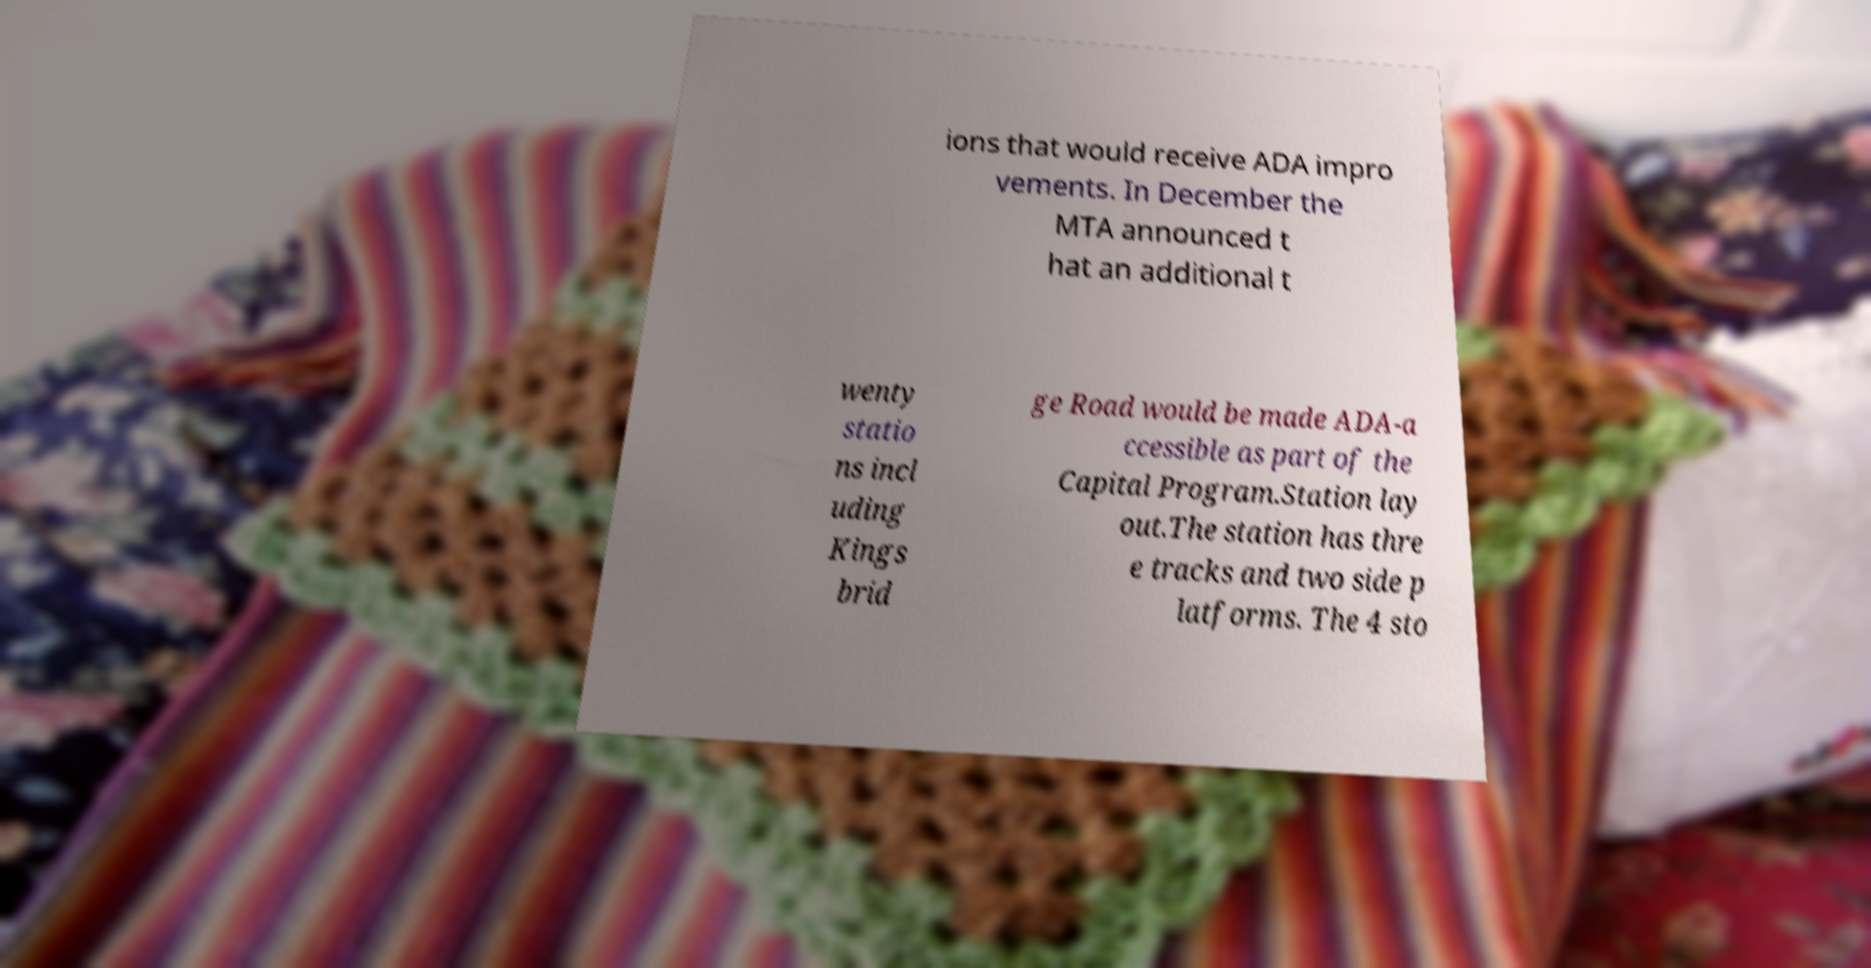Could you assist in decoding the text presented in this image and type it out clearly? ions that would receive ADA impro vements. In December the MTA announced t hat an additional t wenty statio ns incl uding Kings brid ge Road would be made ADA-a ccessible as part of the Capital Program.Station lay out.The station has thre e tracks and two side p latforms. The 4 sto 